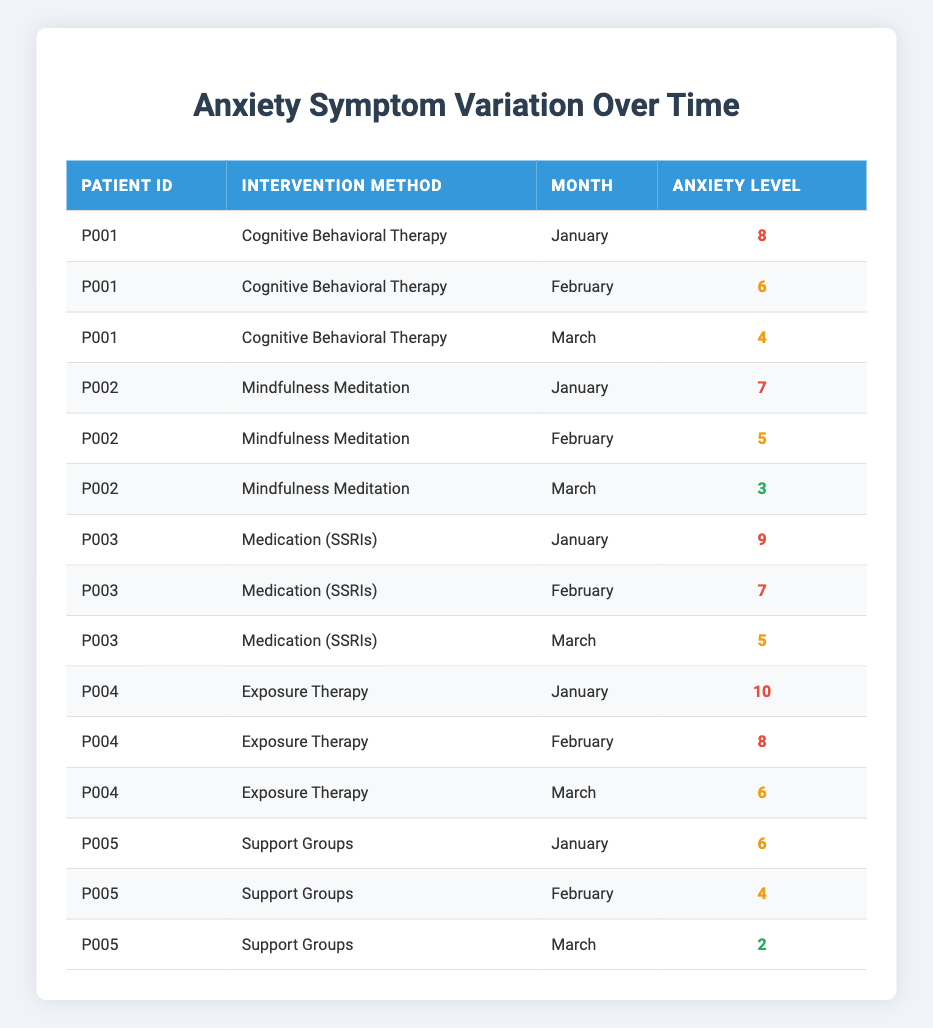What was the anxiety level for Patient P001 in March? The table shows that for Patient P001, the anxiety level for March while undergoing Cognitive Behavioral Therapy was recorded as 4.
Answer: 4 What is the highest anxiety level recorded for Patient P004? From the table, Patient P004's highest anxiety level was 10 in January during Exposure Therapy.
Answer: 10 Did Patient P005 show any improvement in anxiety levels over the three months? Patient P005's anxiety levels decreased from 6 in January to 4 in February and then to 2 in March, indicating a clear improvement over time.
Answer: Yes Which intervention method had the lowest average anxiety level over the three months? By calculating the average for each method: Cognitive Behavioral Therapy (6), Mindfulness Meditation (5), Medication (SSRIs) (7), Exposure Therapy (8), and Support Groups (4). Support Groups had the lowest average anxiety level of 4.
Answer: Support Groups How many patients showed a decline in their anxiety levels from January to March? Analyzing each patient: P001 (8 to 4), P002 (7 to 3), P005 (6 to 2) showed a decline. Patients P003 (9 to 5) and P004 (10 to 6) did not have a consistent decline, leading to a total of 3 patients with decreasing levels.
Answer: 3 What is the difference in anxiety levels between January and February for Patient P003? For Patient P003, the anxiety levels were 9 in January and 7 in February, resulting in a difference of 9 - 7 = 2.
Answer: 2 Was there any month where all patients experienced a high anxiety level (7 or above)? Reviewing the data reveals that in January, all patients had anxiety levels of 6 or higher, thus January is the only month where every patient experienced high anxiety levels.
Answer: Yes What was the trend in anxiety levels for Patient P002 over the three months? Patient P002's anxiety levels started at 7 in January, decreased to 5 in February, and continued to decrease to 3 in March, indicating a consistent downward trend.
Answer: Decreasing Which month had the highest recorded anxiety level across all patients? By reviewing the months in the table, January had the highest anxiety levels, specifically Patient P004 with a level of 10, which was the highest overall.
Answer: January Did any patient’s anxiety level remain constant over the three months? Reviewing the table shows that none of the patients had the same anxiety level across all three months; each patient exhibited changes in their levels.
Answer: No 